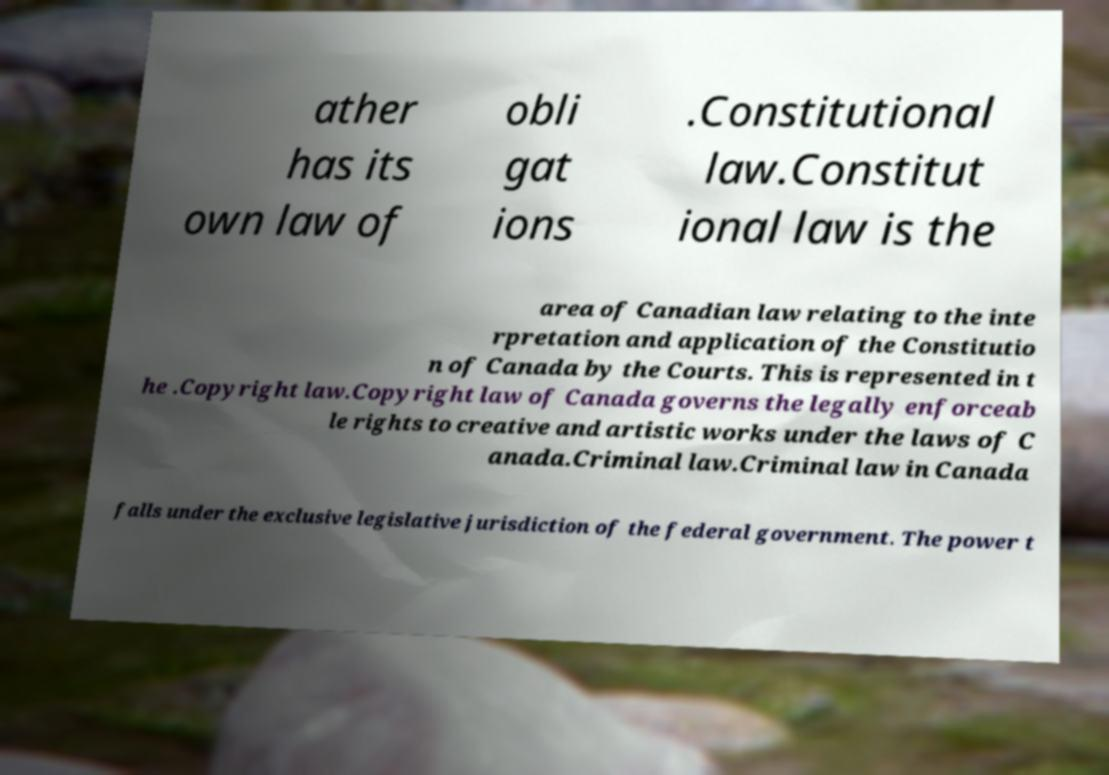Please identify and transcribe the text found in this image. ather has its own law of obli gat ions .Constitutional law.Constitut ional law is the area of Canadian law relating to the inte rpretation and application of the Constitutio n of Canada by the Courts. This is represented in t he .Copyright law.Copyright law of Canada governs the legally enforceab le rights to creative and artistic works under the laws of C anada.Criminal law.Criminal law in Canada falls under the exclusive legislative jurisdiction of the federal government. The power t 